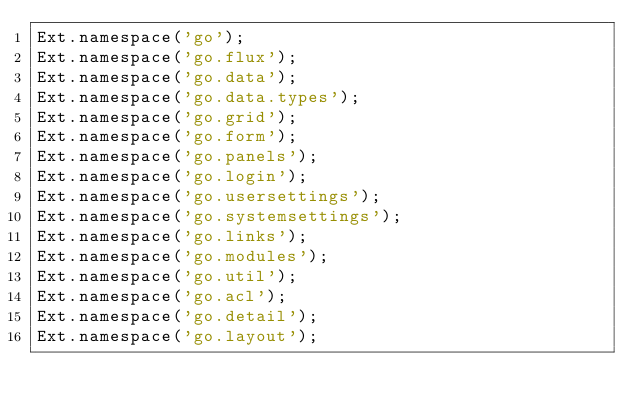<code> <loc_0><loc_0><loc_500><loc_500><_JavaScript_>Ext.namespace('go');
Ext.namespace('go.flux');
Ext.namespace('go.data');
Ext.namespace('go.data.types');
Ext.namespace('go.grid');
Ext.namespace('go.form');
Ext.namespace('go.panels');
Ext.namespace('go.login');
Ext.namespace('go.usersettings');
Ext.namespace('go.systemsettings');
Ext.namespace('go.links');
Ext.namespace('go.modules');
Ext.namespace('go.util');
Ext.namespace('go.acl');
Ext.namespace('go.detail');
Ext.namespace('go.layout');
</code> 